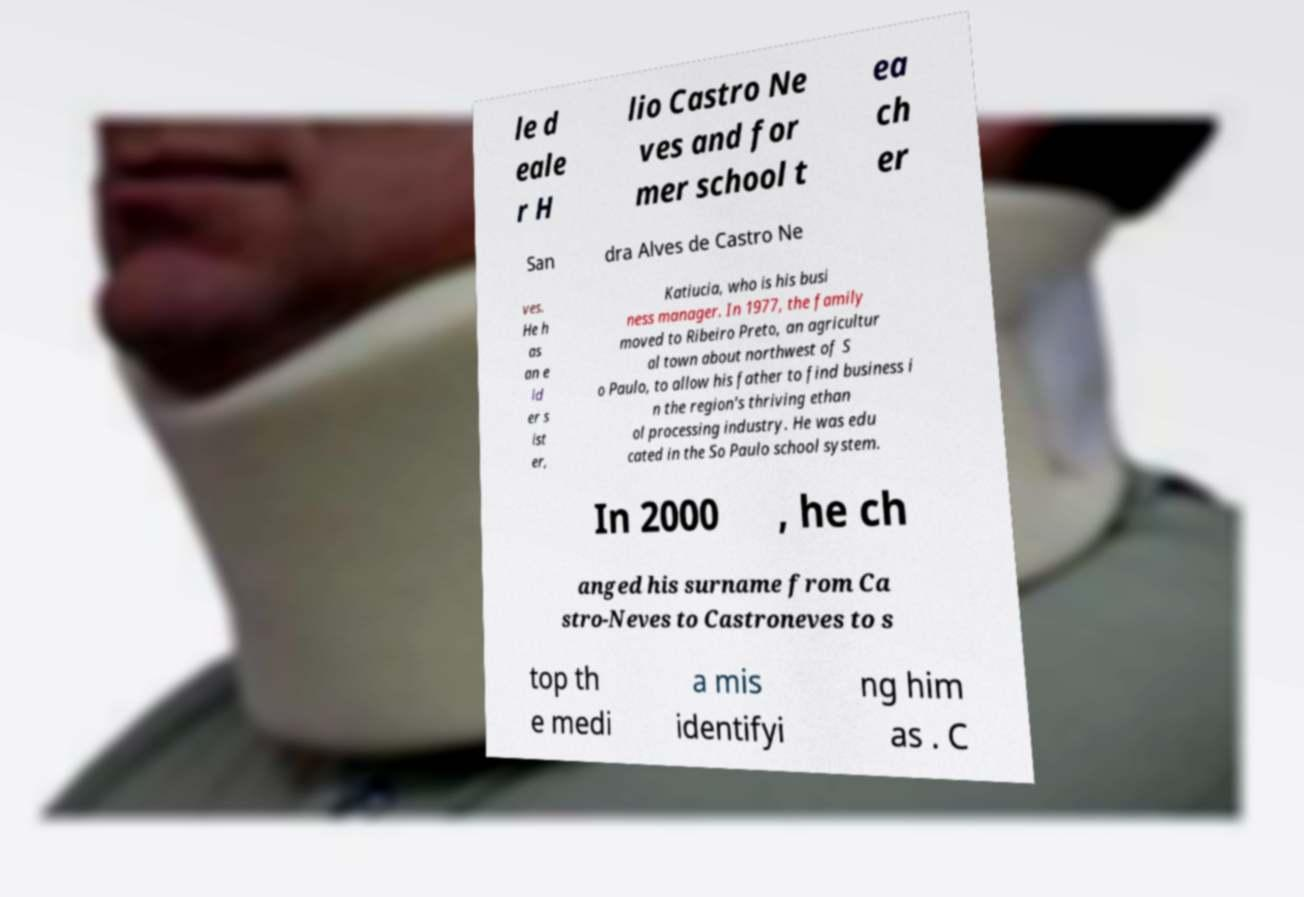Could you assist in decoding the text presented in this image and type it out clearly? le d eale r H lio Castro Ne ves and for mer school t ea ch er San dra Alves de Castro Ne ves. He h as an e ld er s ist er, Katiucia, who is his busi ness manager. In 1977, the family moved to Ribeiro Preto, an agricultur al town about northwest of S o Paulo, to allow his father to find business i n the region's thriving ethan ol processing industry. He was edu cated in the So Paulo school system. In 2000 , he ch anged his surname from Ca stro-Neves to Castroneves to s top th e medi a mis identifyi ng him as . C 